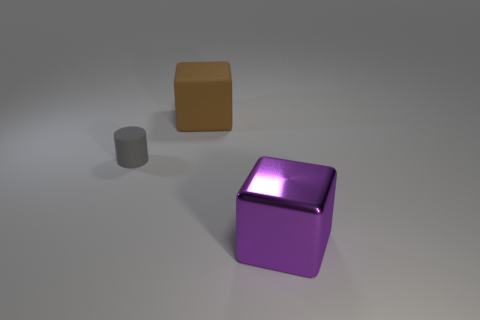Are there any balls of the same color as the tiny cylinder?
Provide a short and direct response. No. Are there an equal number of large purple blocks that are to the left of the purple metal object and big metal cubes?
Offer a very short reply. No. What number of big purple cubes are there?
Your answer should be very brief. 1. What is the shape of the object that is both right of the tiny gray cylinder and to the left of the big shiny thing?
Provide a short and direct response. Cube. Does the cube to the left of the purple thing have the same color as the object in front of the gray cylinder?
Keep it short and to the point. No. Are there any big green cylinders made of the same material as the small gray cylinder?
Keep it short and to the point. No. Is the number of cubes that are on the right side of the brown rubber cube the same as the number of tiny rubber things that are to the right of the small rubber cylinder?
Your response must be concise. No. How big is the cube that is in front of the large brown matte thing?
Provide a short and direct response. Large. The cube on the left side of the big thing that is in front of the large rubber cube is made of what material?
Offer a very short reply. Rubber. How many purple cubes are to the left of the large block on the left side of the big block that is in front of the large brown rubber object?
Provide a short and direct response. 0. 